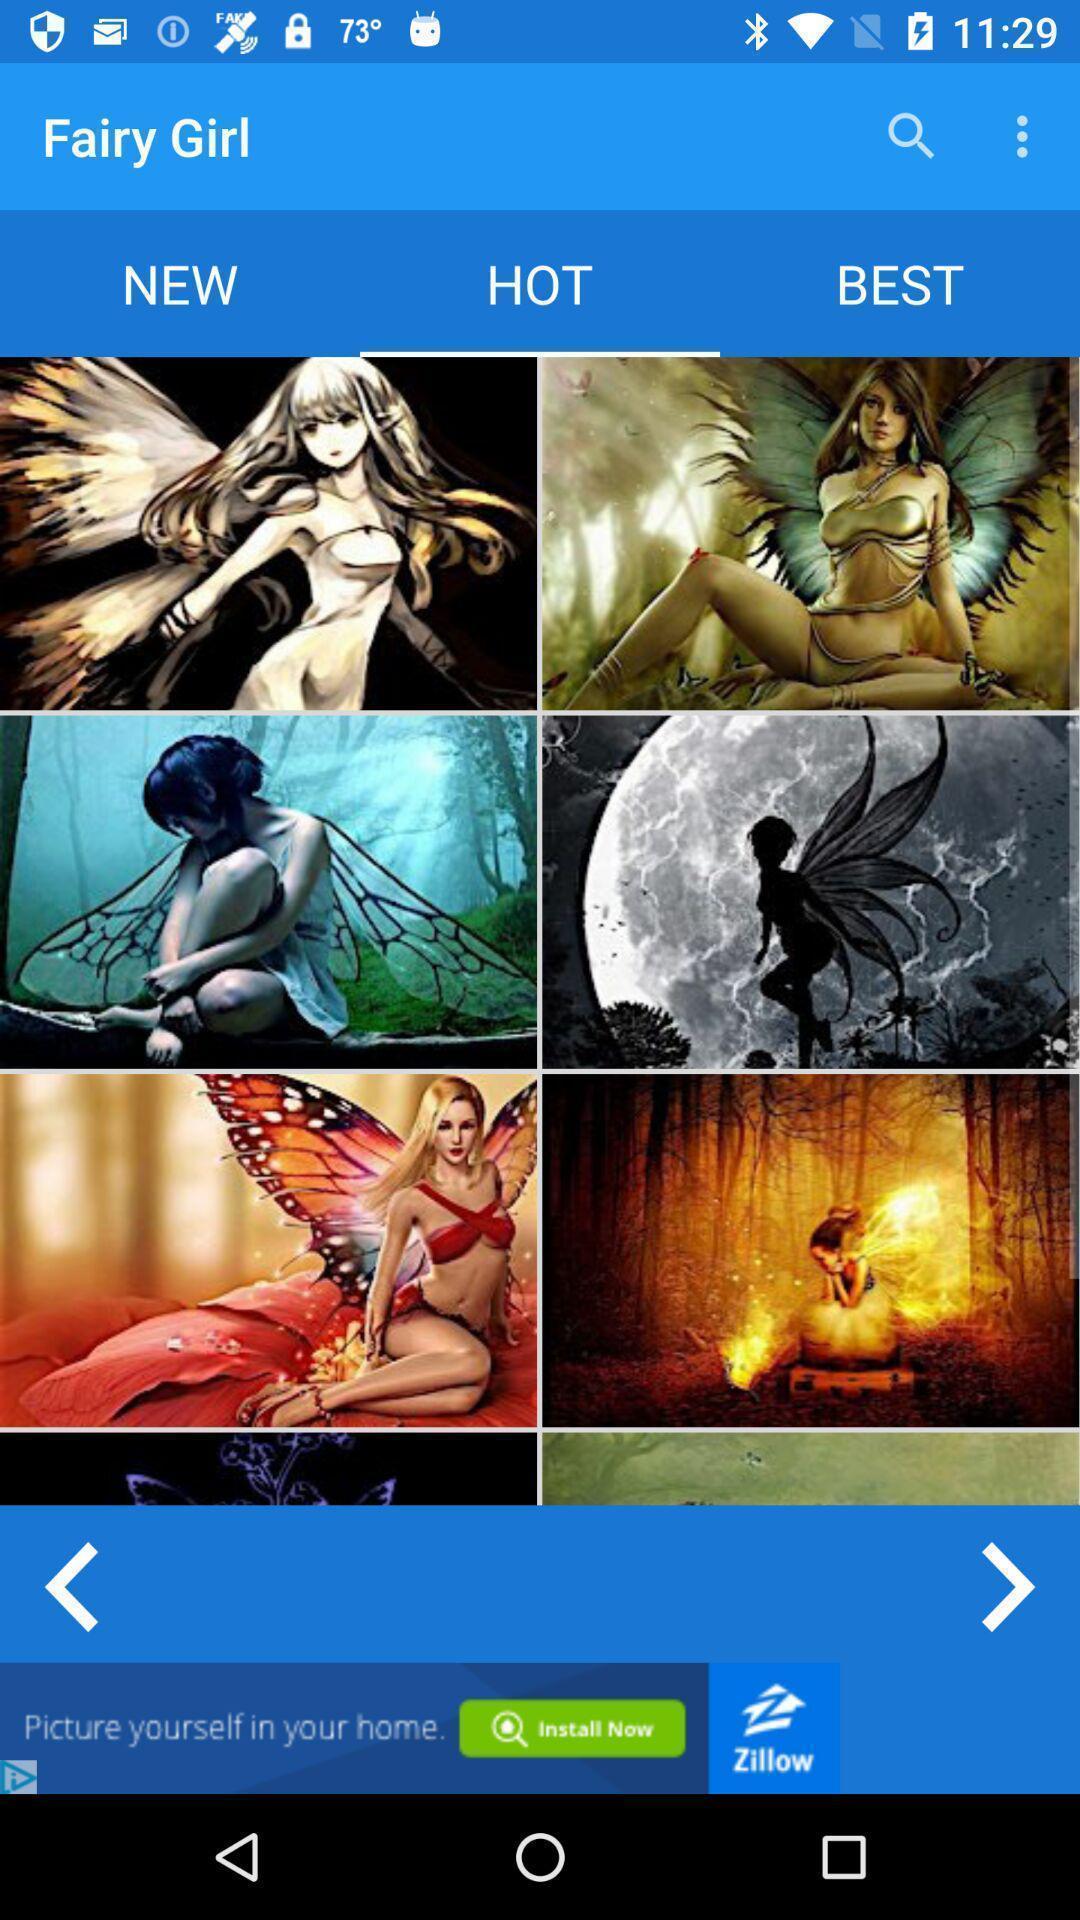Provide a detailed account of this screenshot. Search bar with various categories options. 